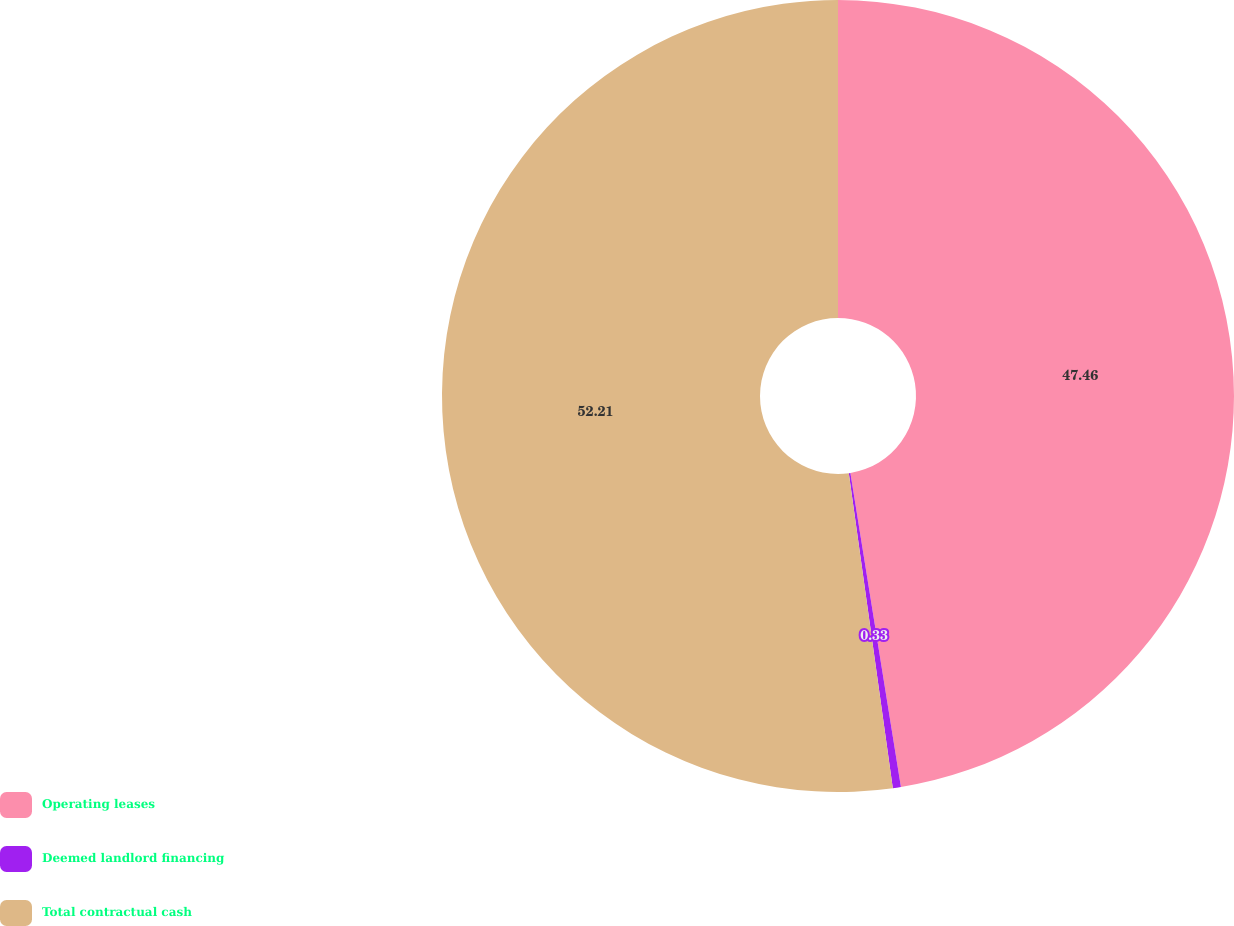Convert chart. <chart><loc_0><loc_0><loc_500><loc_500><pie_chart><fcel>Operating leases<fcel>Deemed landlord financing<fcel>Total contractual cash<nl><fcel>47.46%<fcel>0.33%<fcel>52.21%<nl></chart> 